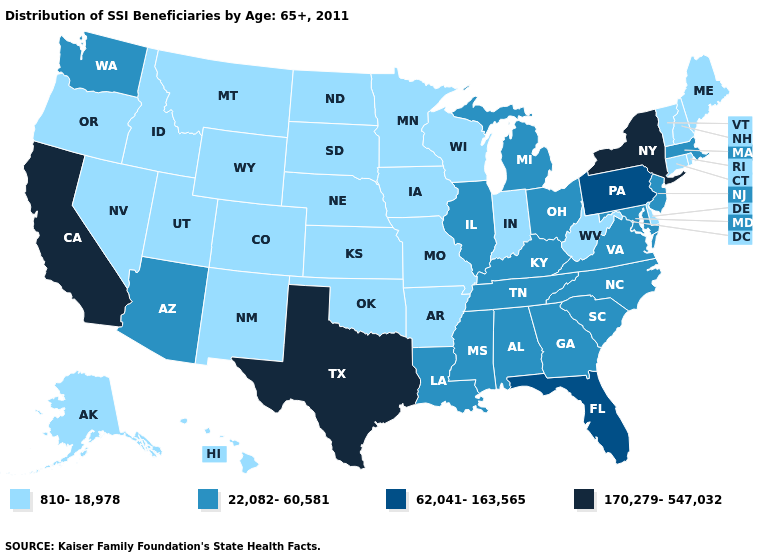What is the highest value in states that border Kansas?
Concise answer only. 810-18,978. Which states have the lowest value in the USA?
Answer briefly. Alaska, Arkansas, Colorado, Connecticut, Delaware, Hawaii, Idaho, Indiana, Iowa, Kansas, Maine, Minnesota, Missouri, Montana, Nebraska, Nevada, New Hampshire, New Mexico, North Dakota, Oklahoma, Oregon, Rhode Island, South Dakota, Utah, Vermont, West Virginia, Wisconsin, Wyoming. What is the lowest value in the USA?
Concise answer only. 810-18,978. What is the value of North Carolina?
Be succinct. 22,082-60,581. Does Connecticut have the same value as Washington?
Write a very short answer. No. Which states hav the highest value in the Northeast?
Answer briefly. New York. Name the states that have a value in the range 170,279-547,032?
Be succinct. California, New York, Texas. Which states have the lowest value in the USA?
Give a very brief answer. Alaska, Arkansas, Colorado, Connecticut, Delaware, Hawaii, Idaho, Indiana, Iowa, Kansas, Maine, Minnesota, Missouri, Montana, Nebraska, Nevada, New Hampshire, New Mexico, North Dakota, Oklahoma, Oregon, Rhode Island, South Dakota, Utah, Vermont, West Virginia, Wisconsin, Wyoming. Name the states that have a value in the range 170,279-547,032?
Be succinct. California, New York, Texas. Name the states that have a value in the range 810-18,978?
Be succinct. Alaska, Arkansas, Colorado, Connecticut, Delaware, Hawaii, Idaho, Indiana, Iowa, Kansas, Maine, Minnesota, Missouri, Montana, Nebraska, Nevada, New Hampshire, New Mexico, North Dakota, Oklahoma, Oregon, Rhode Island, South Dakota, Utah, Vermont, West Virginia, Wisconsin, Wyoming. What is the value of Arkansas?
Be succinct. 810-18,978. Name the states that have a value in the range 62,041-163,565?
Write a very short answer. Florida, Pennsylvania. What is the value of Maryland?
Give a very brief answer. 22,082-60,581. Among the states that border Washington , which have the lowest value?
Give a very brief answer. Idaho, Oregon. What is the lowest value in the USA?
Short answer required. 810-18,978. 